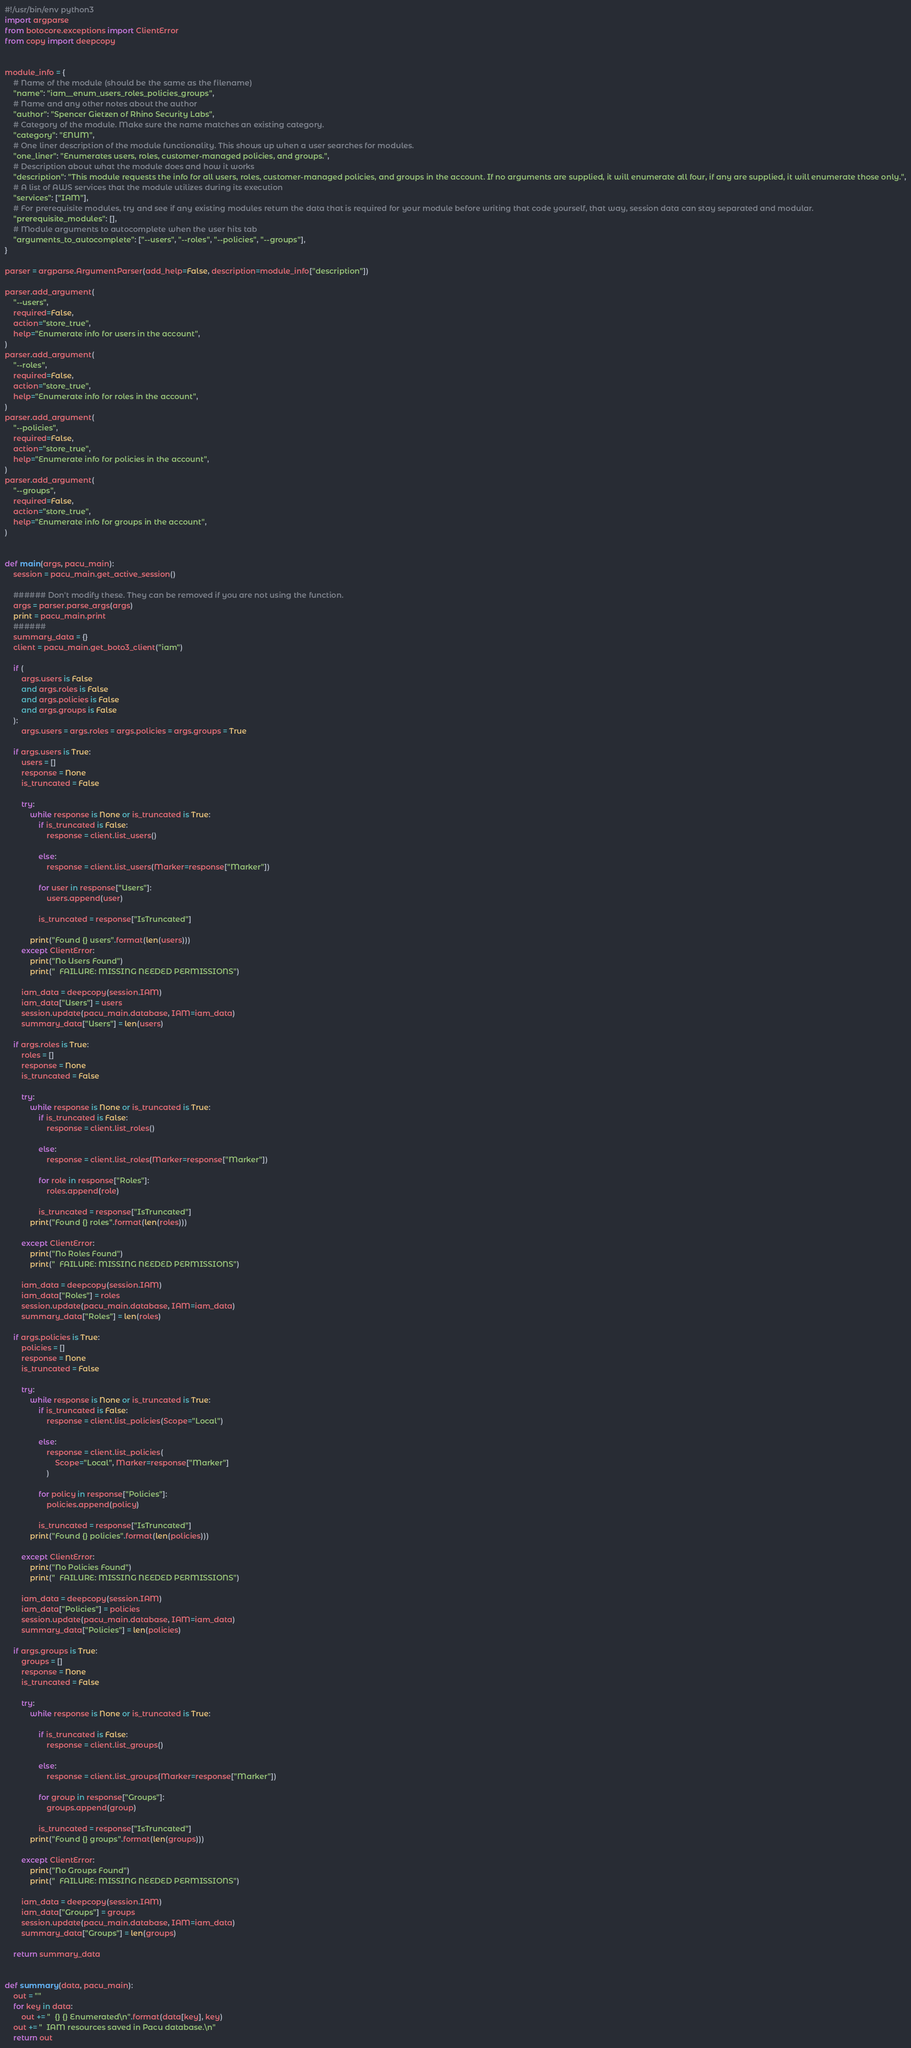Convert code to text. <code><loc_0><loc_0><loc_500><loc_500><_Python_>#!/usr/bin/env python3
import argparse
from botocore.exceptions import ClientError
from copy import deepcopy


module_info = {
    # Name of the module (should be the same as the filename)
    "name": "iam__enum_users_roles_policies_groups",
    # Name and any other notes about the author
    "author": "Spencer Gietzen of Rhino Security Labs",
    # Category of the module. Make sure the name matches an existing category.
    "category": "ENUM",
    # One liner description of the module functionality. This shows up when a user searches for modules.
    "one_liner": "Enumerates users, roles, customer-managed policies, and groups.",
    # Description about what the module does and how it works
    "description": "This module requests the info for all users, roles, customer-managed policies, and groups in the account. If no arguments are supplied, it will enumerate all four, if any are supplied, it will enumerate those only.",
    # A list of AWS services that the module utilizes during its execution
    "services": ["IAM"],
    # For prerequisite modules, try and see if any existing modules return the data that is required for your module before writing that code yourself, that way, session data can stay separated and modular.
    "prerequisite_modules": [],
    # Module arguments to autocomplete when the user hits tab
    "arguments_to_autocomplete": ["--users", "--roles", "--policies", "--groups"],
}

parser = argparse.ArgumentParser(add_help=False, description=module_info["description"])

parser.add_argument(
    "--users",
    required=False,
    action="store_true",
    help="Enumerate info for users in the account",
)
parser.add_argument(
    "--roles",
    required=False,
    action="store_true",
    help="Enumerate info for roles in the account",
)
parser.add_argument(
    "--policies",
    required=False,
    action="store_true",
    help="Enumerate info for policies in the account",
)
parser.add_argument(
    "--groups",
    required=False,
    action="store_true",
    help="Enumerate info for groups in the account",
)


def main(args, pacu_main):
    session = pacu_main.get_active_session()

    ###### Don't modify these. They can be removed if you are not using the function.
    args = parser.parse_args(args)
    print = pacu_main.print
    ######
    summary_data = {}
    client = pacu_main.get_boto3_client("iam")

    if (
        args.users is False
        and args.roles is False
        and args.policies is False
        and args.groups is False
    ):
        args.users = args.roles = args.policies = args.groups = True

    if args.users is True:
        users = []
        response = None
        is_truncated = False

        try:
            while response is None or is_truncated is True:
                if is_truncated is False:
                    response = client.list_users()

                else:
                    response = client.list_users(Marker=response["Marker"])

                for user in response["Users"]:
                    users.append(user)

                is_truncated = response["IsTruncated"]

            print("Found {} users".format(len(users)))
        except ClientError:
            print("No Users Found")
            print("  FAILURE: MISSING NEEDED PERMISSIONS")

        iam_data = deepcopy(session.IAM)
        iam_data["Users"] = users
        session.update(pacu_main.database, IAM=iam_data)
        summary_data["Users"] = len(users)

    if args.roles is True:
        roles = []
        response = None
        is_truncated = False

        try:
            while response is None or is_truncated is True:
                if is_truncated is False:
                    response = client.list_roles()

                else:
                    response = client.list_roles(Marker=response["Marker"])

                for role in response["Roles"]:
                    roles.append(role)

                is_truncated = response["IsTruncated"]
            print("Found {} roles".format(len(roles)))

        except ClientError:
            print("No Roles Found")
            print("  FAILURE: MISSING NEEDED PERMISSIONS")

        iam_data = deepcopy(session.IAM)
        iam_data["Roles"] = roles
        session.update(pacu_main.database, IAM=iam_data)
        summary_data["Roles"] = len(roles)

    if args.policies is True:
        policies = []
        response = None
        is_truncated = False

        try:
            while response is None or is_truncated is True:
                if is_truncated is False:
                    response = client.list_policies(Scope="Local")

                else:
                    response = client.list_policies(
                        Scope="Local", Marker=response["Marker"]
                    )

                for policy in response["Policies"]:
                    policies.append(policy)

                is_truncated = response["IsTruncated"]
            print("Found {} policies".format(len(policies)))

        except ClientError:
            print("No Policies Found")
            print("  FAILURE: MISSING NEEDED PERMISSIONS")

        iam_data = deepcopy(session.IAM)
        iam_data["Policies"] = policies
        session.update(pacu_main.database, IAM=iam_data)
        summary_data["Policies"] = len(policies)

    if args.groups is True:
        groups = []
        response = None
        is_truncated = False

        try:
            while response is None or is_truncated is True:

                if is_truncated is False:
                    response = client.list_groups()

                else:
                    response = client.list_groups(Marker=response["Marker"])

                for group in response["Groups"]:
                    groups.append(group)

                is_truncated = response["IsTruncated"]
            print("Found {} groups".format(len(groups)))

        except ClientError:
            print("No Groups Found")
            print("  FAILURE: MISSING NEEDED PERMISSIONS")

        iam_data = deepcopy(session.IAM)
        iam_data["Groups"] = groups
        session.update(pacu_main.database, IAM=iam_data)
        summary_data["Groups"] = len(groups)

    return summary_data


def summary(data, pacu_main):
    out = ""
    for key in data:
        out += "  {} {} Enumerated\n".format(data[key], key)
    out += "  IAM resources saved in Pacu database.\n"
    return out
</code> 